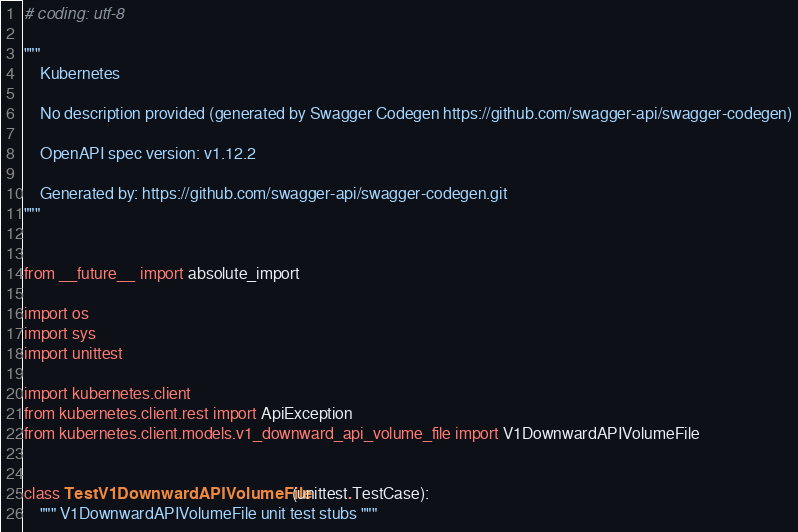Convert code to text. <code><loc_0><loc_0><loc_500><loc_500><_Python_># coding: utf-8

"""
    Kubernetes

    No description provided (generated by Swagger Codegen https://github.com/swagger-api/swagger-codegen)

    OpenAPI spec version: v1.12.2
    
    Generated by: https://github.com/swagger-api/swagger-codegen.git
"""


from __future__ import absolute_import

import os
import sys
import unittest

import kubernetes.client
from kubernetes.client.rest import ApiException
from kubernetes.client.models.v1_downward_api_volume_file import V1DownwardAPIVolumeFile


class TestV1DownwardAPIVolumeFile(unittest.TestCase):
    """ V1DownwardAPIVolumeFile unit test stubs """
</code> 